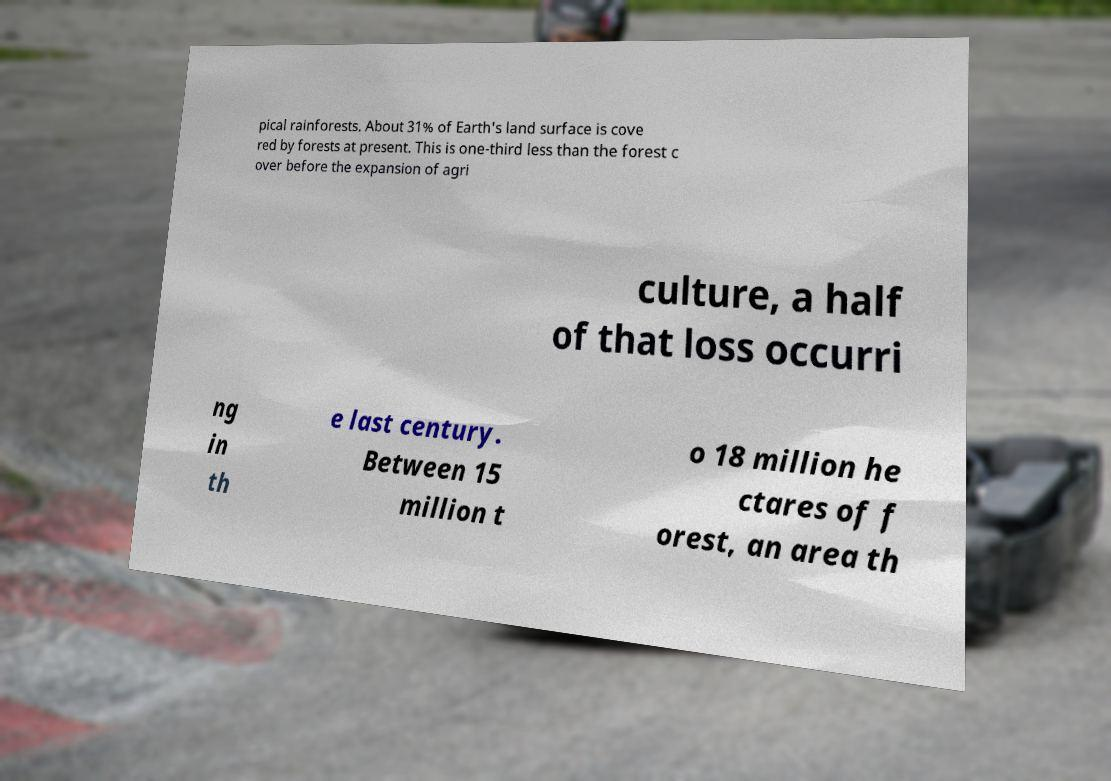Please identify and transcribe the text found in this image. pical rainforests. About 31% of Earth's land surface is cove red by forests at present. This is one-third less than the forest c over before the expansion of agri culture, a half of that loss occurri ng in th e last century. Between 15 million t o 18 million he ctares of f orest, an area th 